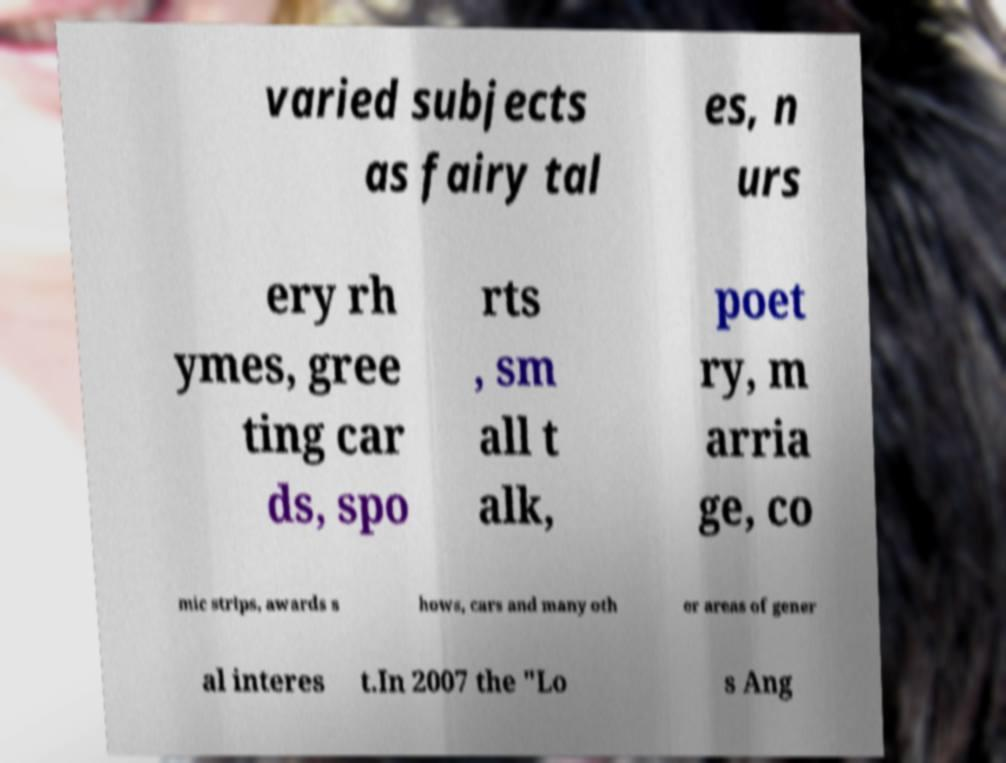There's text embedded in this image that I need extracted. Can you transcribe it verbatim? varied subjects as fairy tal es, n urs ery rh ymes, gree ting car ds, spo rts , sm all t alk, poet ry, m arria ge, co mic strips, awards s hows, cars and many oth er areas of gener al interes t.In 2007 the "Lo s Ang 